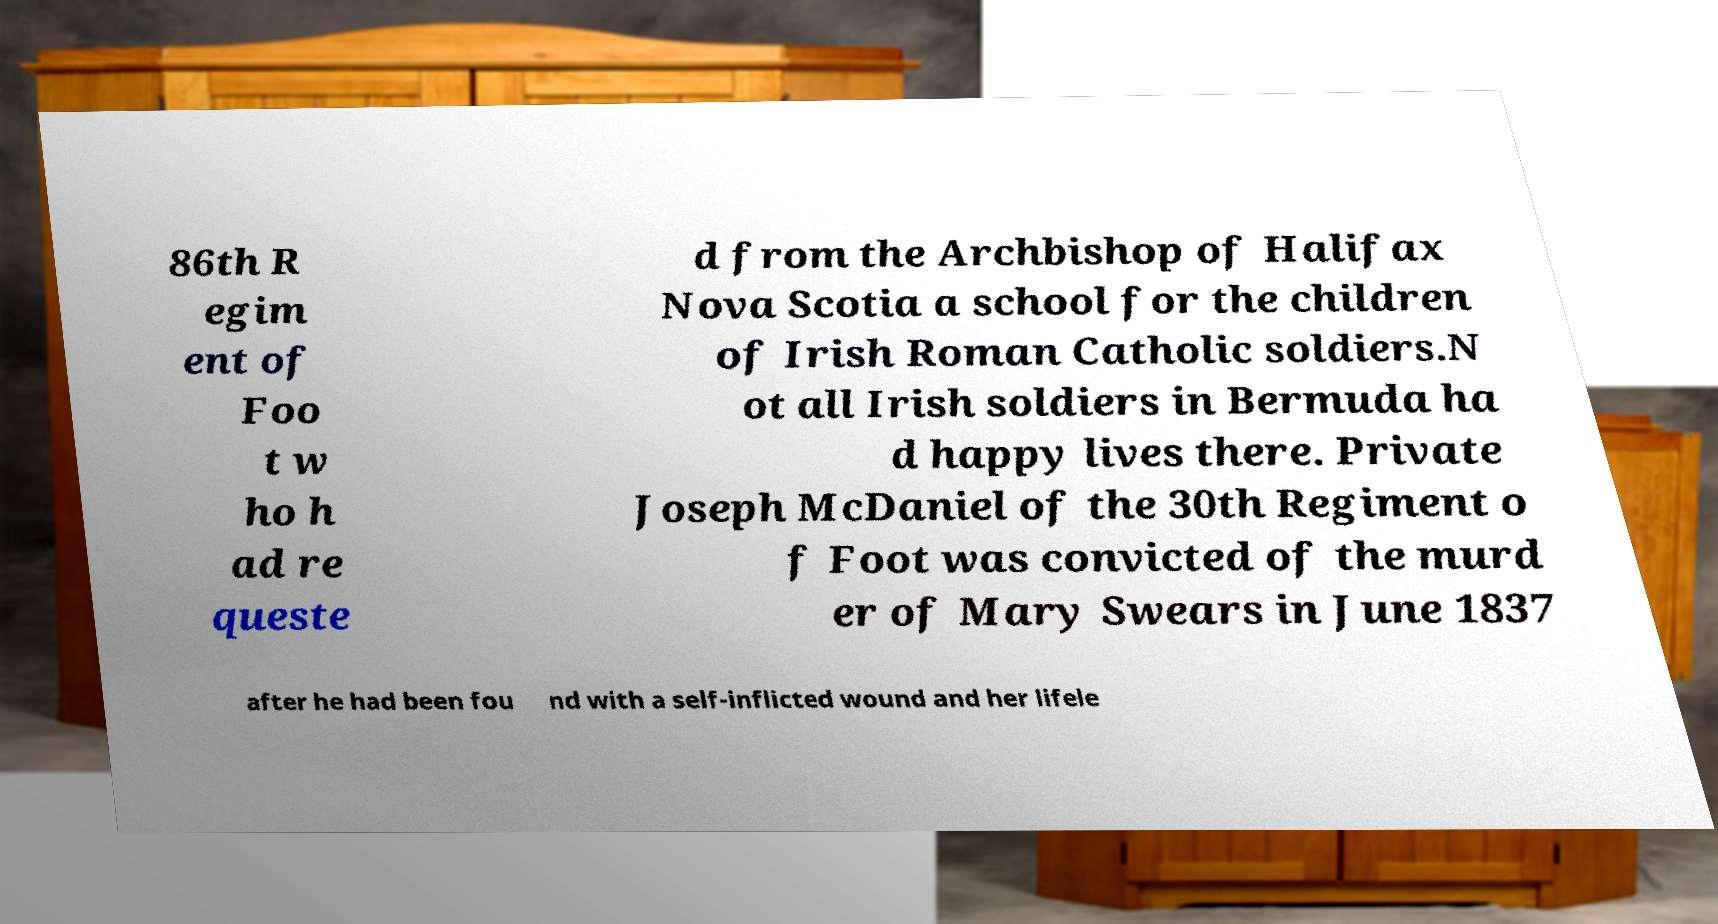Can you accurately transcribe the text from the provided image for me? 86th R egim ent of Foo t w ho h ad re queste d from the Archbishop of Halifax Nova Scotia a school for the children of Irish Roman Catholic soldiers.N ot all Irish soldiers in Bermuda ha d happy lives there. Private Joseph McDaniel of the 30th Regiment o f Foot was convicted of the murd er of Mary Swears in June 1837 after he had been fou nd with a self-inflicted wound and her lifele 